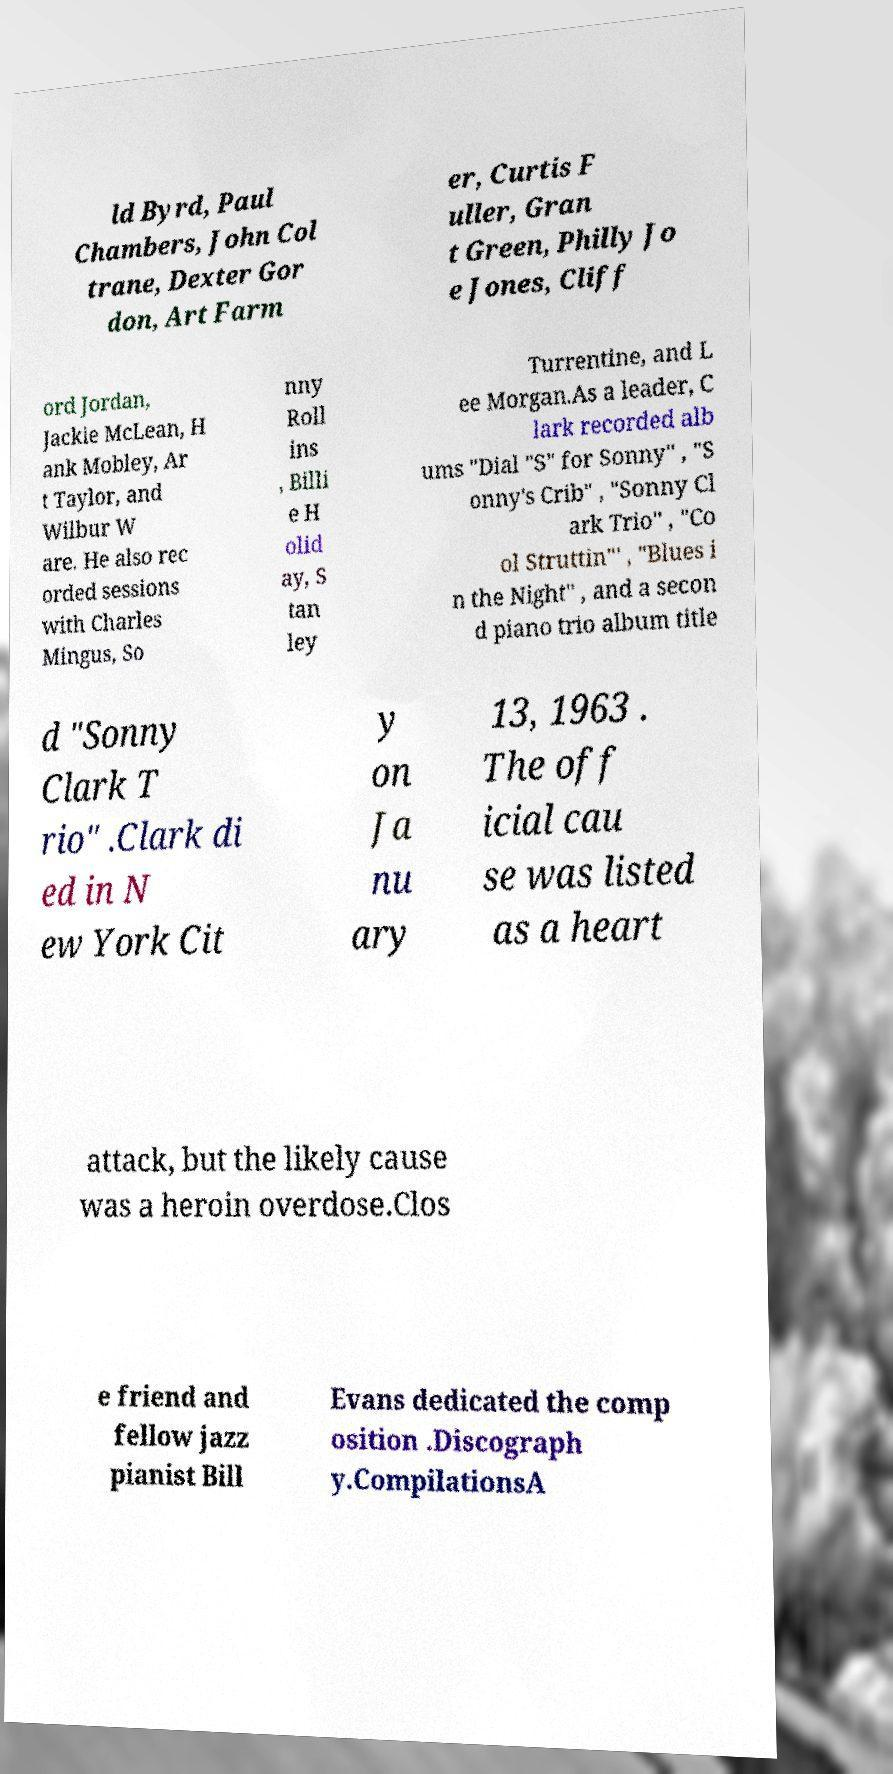Could you assist in decoding the text presented in this image and type it out clearly? ld Byrd, Paul Chambers, John Col trane, Dexter Gor don, Art Farm er, Curtis F uller, Gran t Green, Philly Jo e Jones, Cliff ord Jordan, Jackie McLean, H ank Mobley, Ar t Taylor, and Wilbur W are. He also rec orded sessions with Charles Mingus, So nny Roll ins , Billi e H olid ay, S tan ley Turrentine, and L ee Morgan.As a leader, C lark recorded alb ums "Dial "S" for Sonny" , "S onny's Crib" , "Sonny Cl ark Trio" , "Co ol Struttin"' , "Blues i n the Night" , and a secon d piano trio album title d "Sonny Clark T rio" .Clark di ed in N ew York Cit y on Ja nu ary 13, 1963 . The off icial cau se was listed as a heart attack, but the likely cause was a heroin overdose.Clos e friend and fellow jazz pianist Bill Evans dedicated the comp osition .Discograph y.CompilationsA 